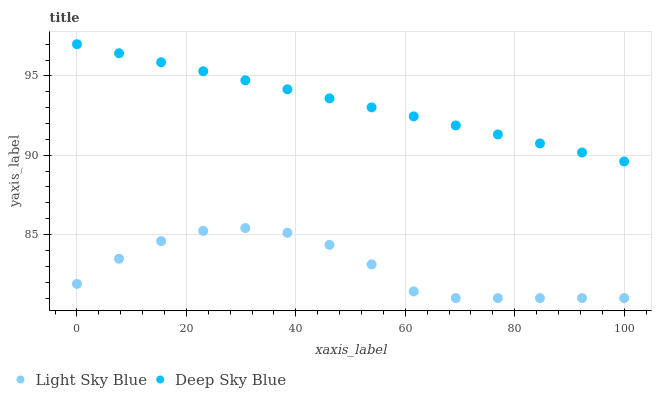Does Light Sky Blue have the minimum area under the curve?
Answer yes or no. Yes. Does Deep Sky Blue have the maximum area under the curve?
Answer yes or no. Yes. Does Deep Sky Blue have the minimum area under the curve?
Answer yes or no. No. Is Deep Sky Blue the smoothest?
Answer yes or no. Yes. Is Light Sky Blue the roughest?
Answer yes or no. Yes. Is Deep Sky Blue the roughest?
Answer yes or no. No. Does Light Sky Blue have the lowest value?
Answer yes or no. Yes. Does Deep Sky Blue have the lowest value?
Answer yes or no. No. Does Deep Sky Blue have the highest value?
Answer yes or no. Yes. Is Light Sky Blue less than Deep Sky Blue?
Answer yes or no. Yes. Is Deep Sky Blue greater than Light Sky Blue?
Answer yes or no. Yes. Does Light Sky Blue intersect Deep Sky Blue?
Answer yes or no. No. 